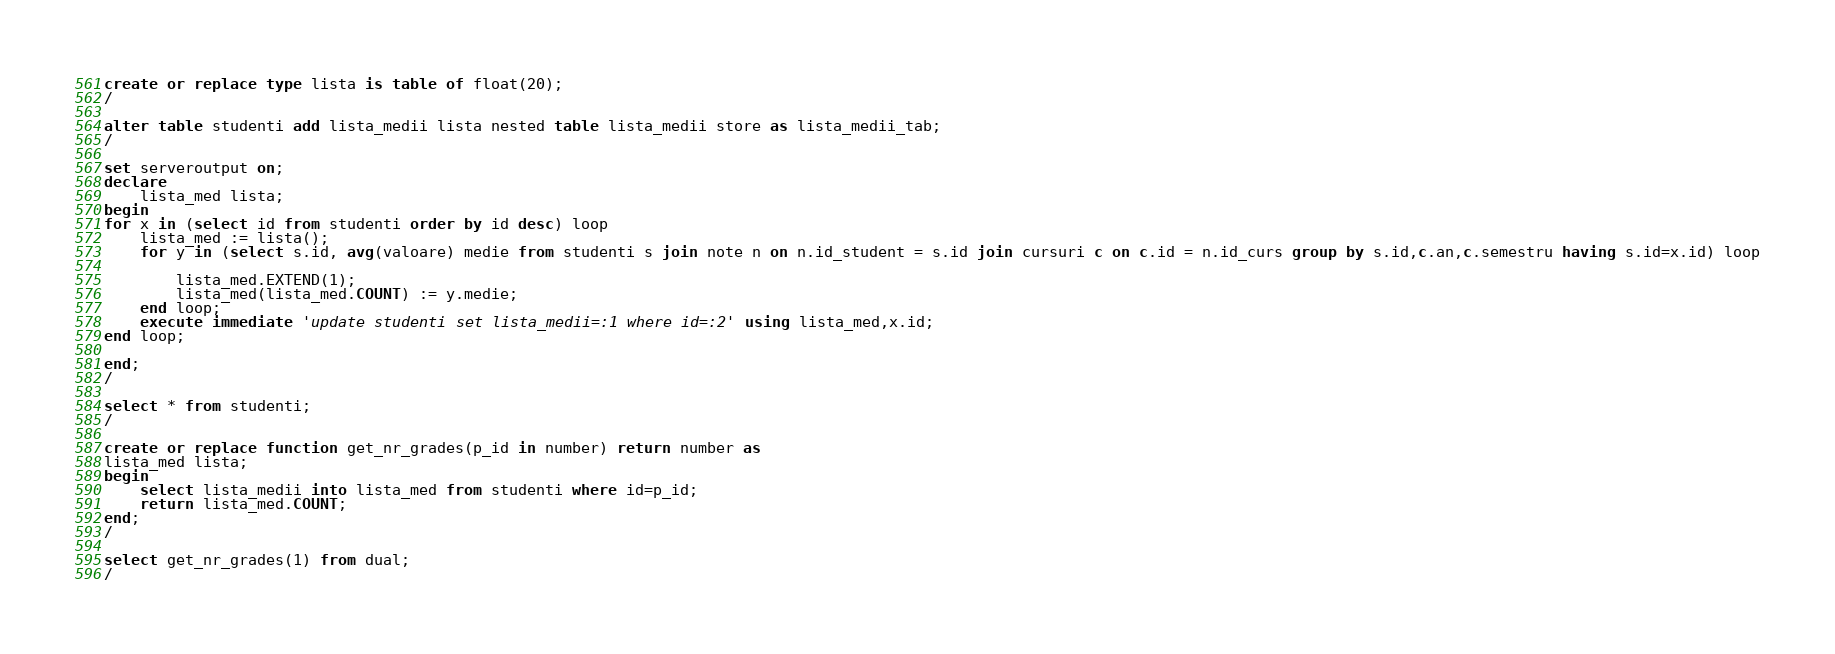Convert code to text. <code><loc_0><loc_0><loc_500><loc_500><_SQL_>create or replace type lista is table of float(20);
/

alter table studenti add lista_medii lista nested table lista_medii store as lista_medii_tab;
/

set serveroutput on;
declare
    lista_med lista;
begin
for x in (select id from studenti order by id desc) loop
    lista_med := lista();
    for y in (select s.id, avg(valoare) medie from studenti s join note n on n.id_student = s.id join cursuri c on c.id = n.id_curs group by s.id,c.an,c.semestru having s.id=x.id) loop
    
        lista_med.EXTEND(1);
        lista_med(lista_med.COUNT) := y.medie;
    end loop;
    execute immediate 'update studenti set lista_medii=:1 where id=:2' using lista_med,x.id;
end loop;

end;
/

select * from studenti;
/

create or replace function get_nr_grades(p_id in number) return number as
lista_med lista;
begin
    select lista_medii into lista_med from studenti where id=p_id;
    return lista_med.COUNT;
end;
/

select get_nr_grades(1) from dual;
/</code> 